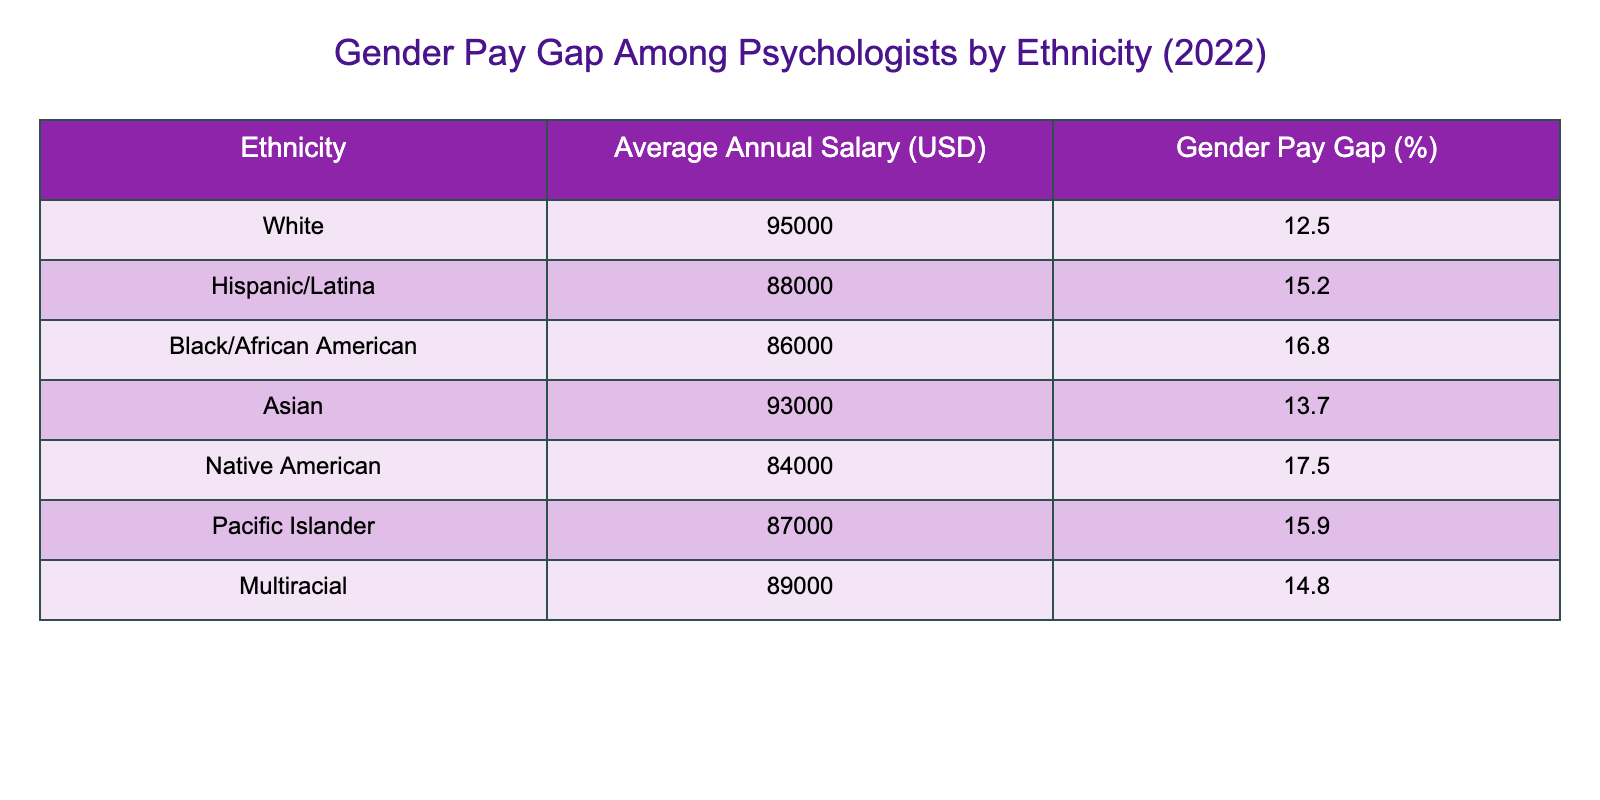What is the average annual salary for Hispanic/Latina psychologists? The table lists the average annual salary specifically for Hispanic/Latina psychologists as $88,000.
Answer: $88,000 Which ethnicity has the highest average annual salary among psychologists listed in the table? The highest average annual salary is for White psychologists, which is $95,000.
Answer: White What is the gender pay gap percentage for Native American psychologists? The gender pay gap percentage for Native American psychologists is 17.5%, as indicated in the table.
Answer: 17.5% Calculate the average salary of Asian and Black/African American psychologists combined. The average salary for Asian psychologists is $93,000 and for Black/African American psychologists is $86,000. Adding these gives $93,000 + $86,000 = $179,000. Dividing by 2 gives an average of $89,500.
Answer: $89,500 Is the gender pay gap for Hispanic/Latina psychologists higher than that of Asian psychologists? The gender pay gap for Hispanic/Latina psychologists is 15.2%, and for Asian psychologists, it is 13.7%. Since 15.2% is greater than 13.7%, the statement is true.
Answer: Yes What is the difference in average annual salary between White and Native American psychologists? The average salary for White psychologists is $95,000 and for Native American psychologists is $84,000. The difference is $95,000 - $84,000 = $11,000.
Answer: $11,000 Which ethnicity has the lowest gender pay gap percentage? The table shows that Native American psychologists have the highest gender pay gap percentage at 17.5%. Hence, the ethnicity with the lowest gender pay gap is Asian, at 13.7%.
Answer: Asian If we consider the average salaries of all ethnicities, what is the median salary? First, we list the average salaries in ascending order: 84000, 86000, 87000, 88000, 89000, 93000, 95000. The median is the middle value, which, in this case, is the average of the 4th and 5th values ($87,000 and $88,000). Thus, median = ($87,000 + $88,000) / 2 = $87,500.
Answer: $87,500 How many ethnicities listed have a gender pay gap greater than 15%? The table indicates that Hispanic/Latina, Black/African American, Native American, and Pacific Islander all have gender pay gaps greater than 15%, which counts to four ethnicities.
Answer: 4 What ethnicity has an average annual salary of $86,000? The table explicitly states that Black/African American psychologists have an average annual salary of $86,000.
Answer: Black/African American Which group has the lowest average annual salary among the ethnicities listed? The table shows that Native American psychologists have the lowest average annual salary of $84,000 compared to all other groups.
Answer: Native American 